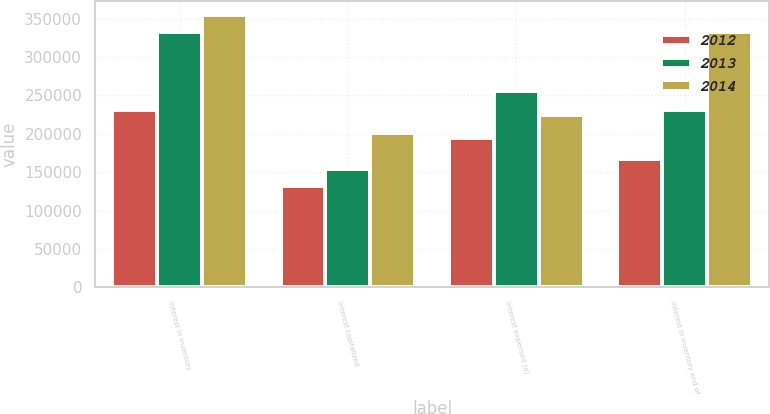Convert chart. <chart><loc_0><loc_0><loc_500><loc_500><stacked_bar_chart><ecel><fcel>Interest in inventory<fcel>Interest capitalized<fcel>Interest expensed (a)<fcel>Interest in inventory end of<nl><fcel>2012<fcel>230922<fcel>131444<fcel>194728<fcel>167638<nl><fcel>2013<fcel>331880<fcel>154107<fcel>255065<fcel>230922<nl><fcel>2014<fcel>355068<fcel>201103<fcel>224291<fcel>331880<nl></chart> 